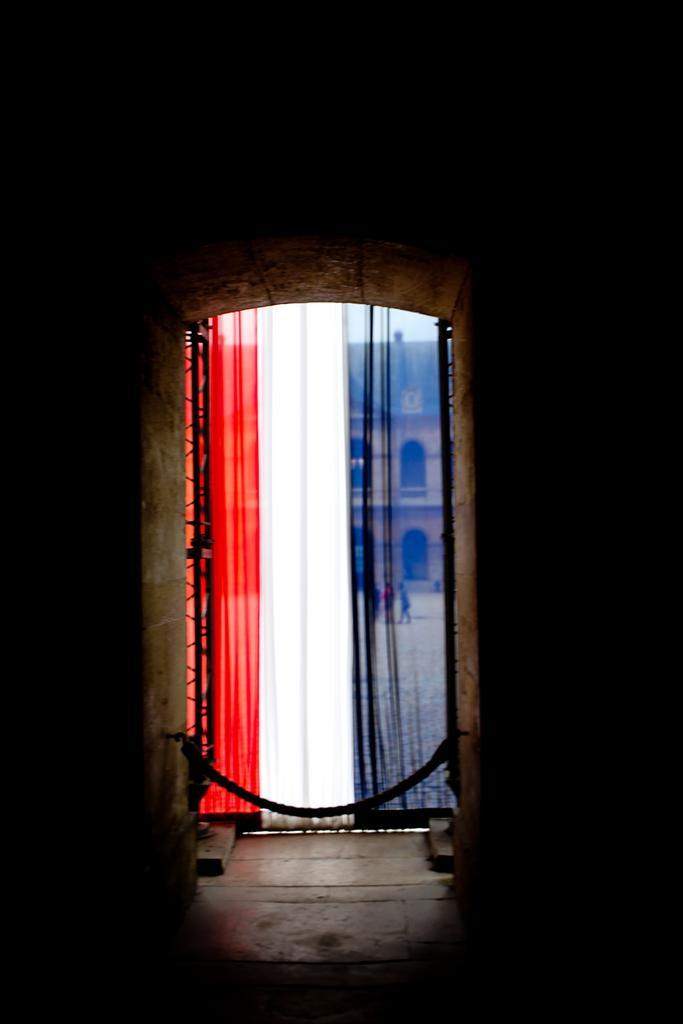In one or two sentences, can you explain what this image depicts? Through this colorful curtain we can see building and people. Around this curtain it is dark. 